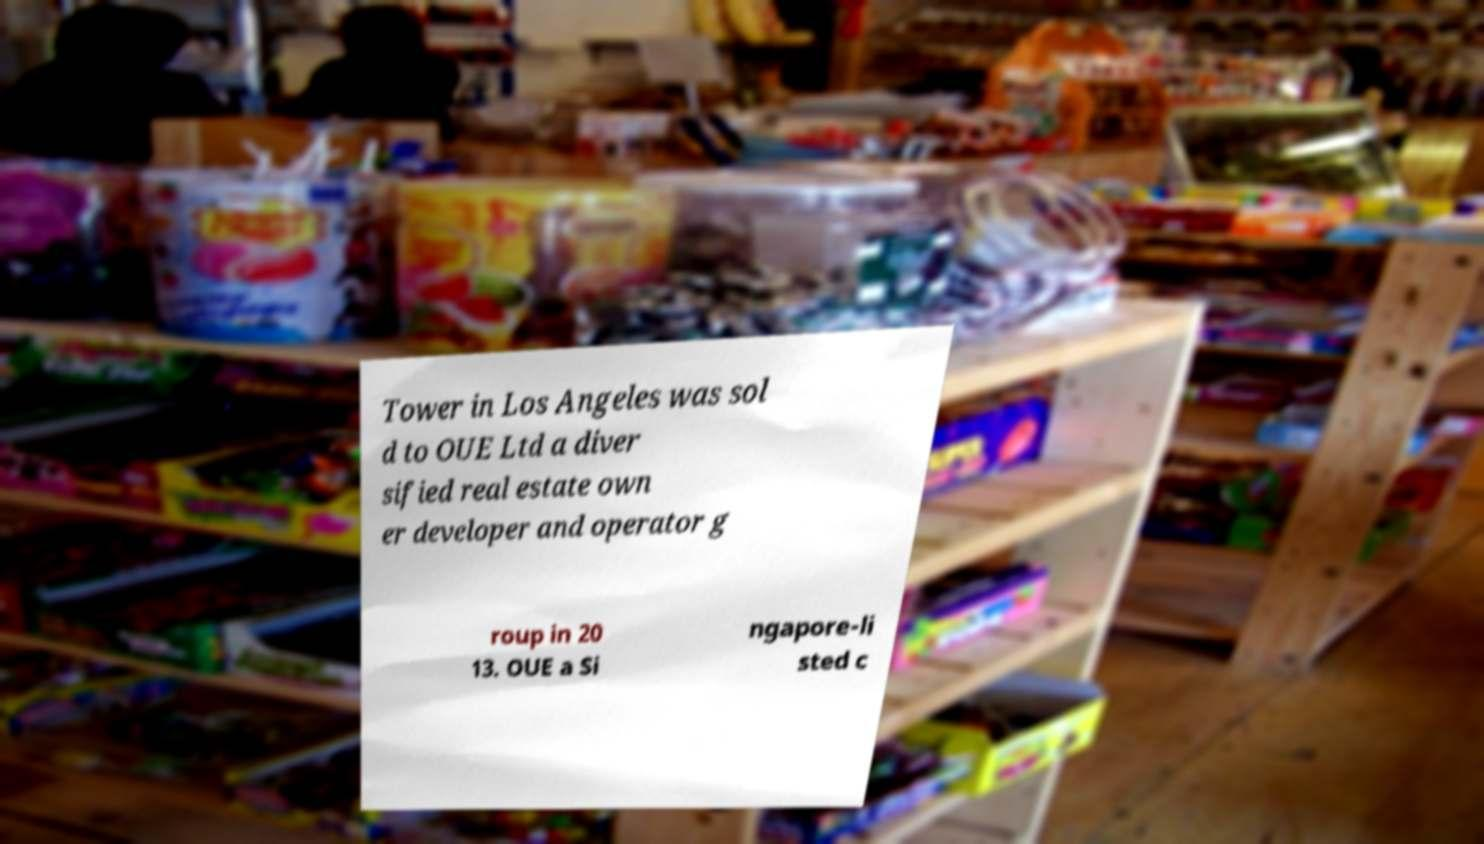Can you accurately transcribe the text from the provided image for me? Tower in Los Angeles was sol d to OUE Ltd a diver sified real estate own er developer and operator g roup in 20 13. OUE a Si ngapore-li sted c 